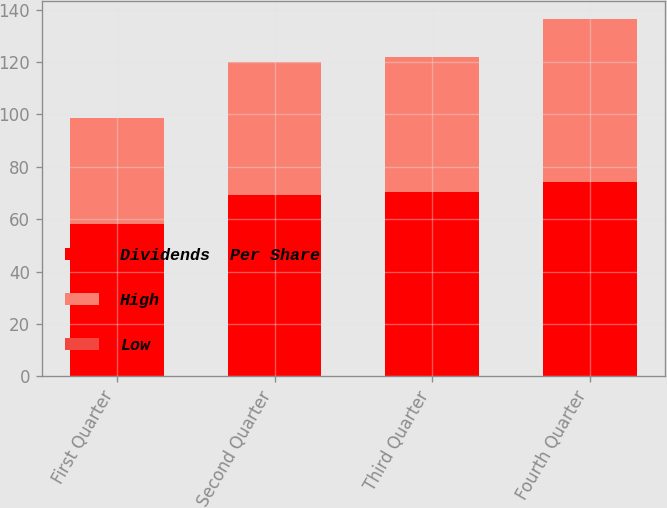Convert chart. <chart><loc_0><loc_0><loc_500><loc_500><stacked_bar_chart><ecel><fcel>First Quarter<fcel>Second Quarter<fcel>Third Quarter<fcel>Fourth Quarter<nl><fcel>Dividends  Per Share<fcel>58.24<fcel>69.07<fcel>70.35<fcel>74.09<nl><fcel>High<fcel>40.33<fcel>50.86<fcel>51.49<fcel>62.25<nl><fcel>Low<fcel>0.18<fcel>0.18<fcel>0.18<fcel>0.18<nl></chart> 